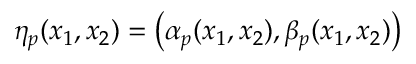<formula> <loc_0><loc_0><loc_500><loc_500>\eta _ { p } ( x _ { 1 } , x _ { 2 } ) = \left ( \alpha _ { p } ( x _ { 1 } , x _ { 2 } ) , \beta _ { p } ( x _ { 1 } , x _ { 2 } ) \right )</formula> 